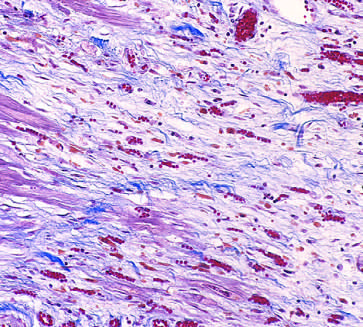what is characterized by loose connective tissue and abundant capillaries?
Answer the question using a single word or phrase. Granulation tissue 